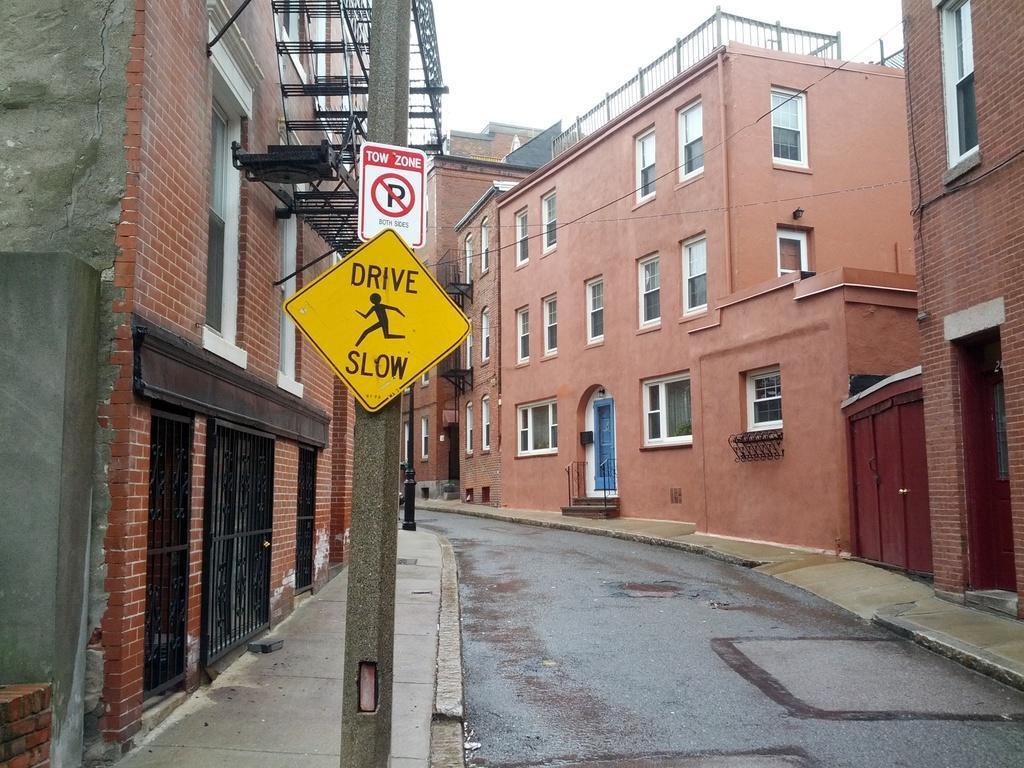In one or two sentences, can you explain what this image depicts? In the image i can see a buildings with windows,doors,gates,electric poles,road and other objects. 